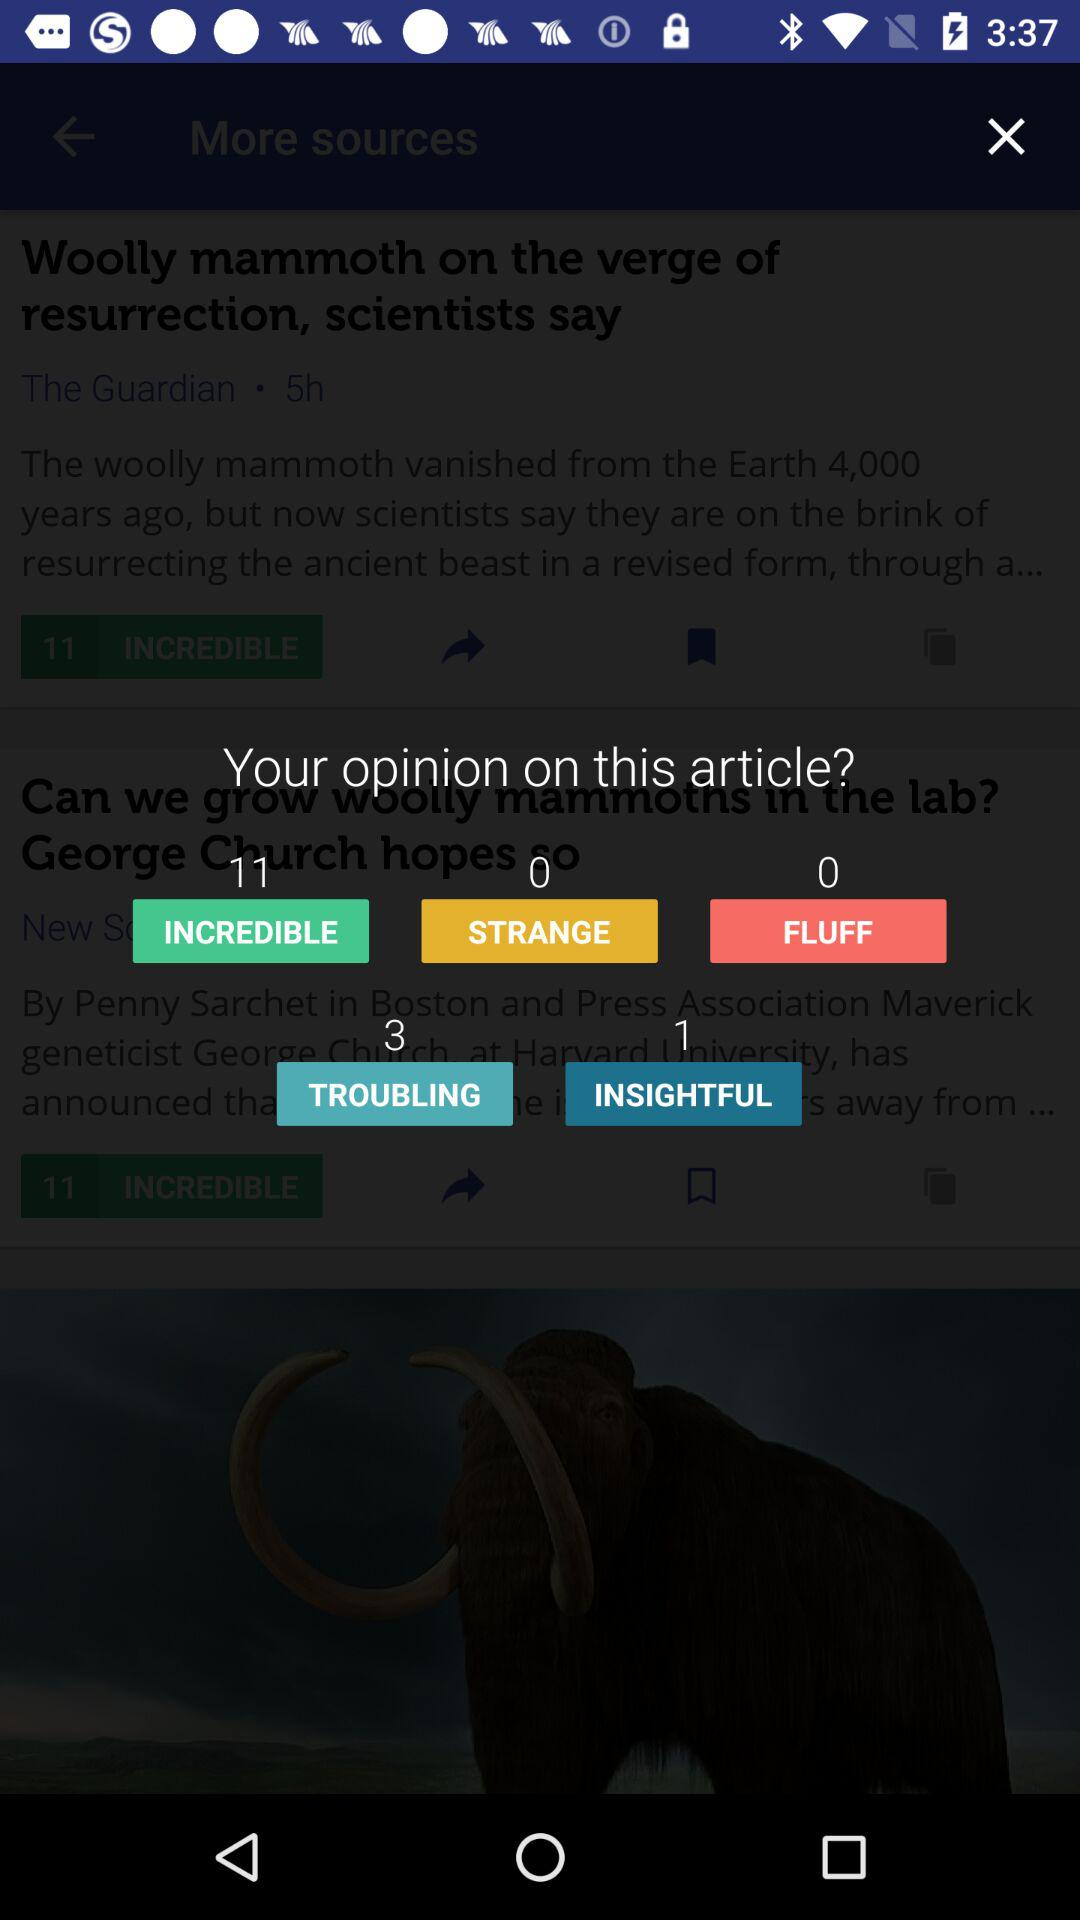What is the total number of people who think the article is "STRANGE"? The total number of people who think the article is "STRANGE" is 0. 